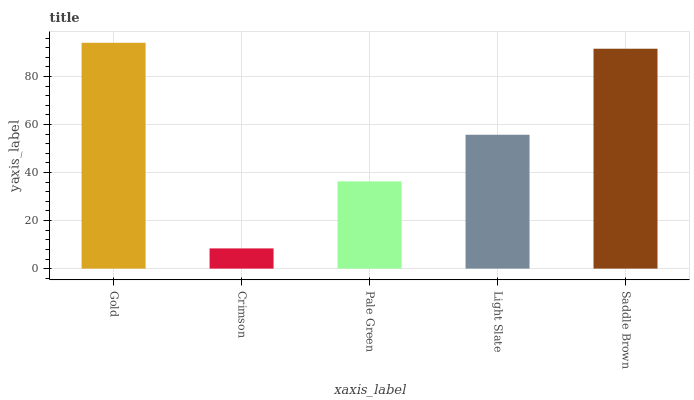Is Crimson the minimum?
Answer yes or no. Yes. Is Gold the maximum?
Answer yes or no. Yes. Is Pale Green the minimum?
Answer yes or no. No. Is Pale Green the maximum?
Answer yes or no. No. Is Pale Green greater than Crimson?
Answer yes or no. Yes. Is Crimson less than Pale Green?
Answer yes or no. Yes. Is Crimson greater than Pale Green?
Answer yes or no. No. Is Pale Green less than Crimson?
Answer yes or no. No. Is Light Slate the high median?
Answer yes or no. Yes. Is Light Slate the low median?
Answer yes or no. Yes. Is Saddle Brown the high median?
Answer yes or no. No. Is Crimson the low median?
Answer yes or no. No. 